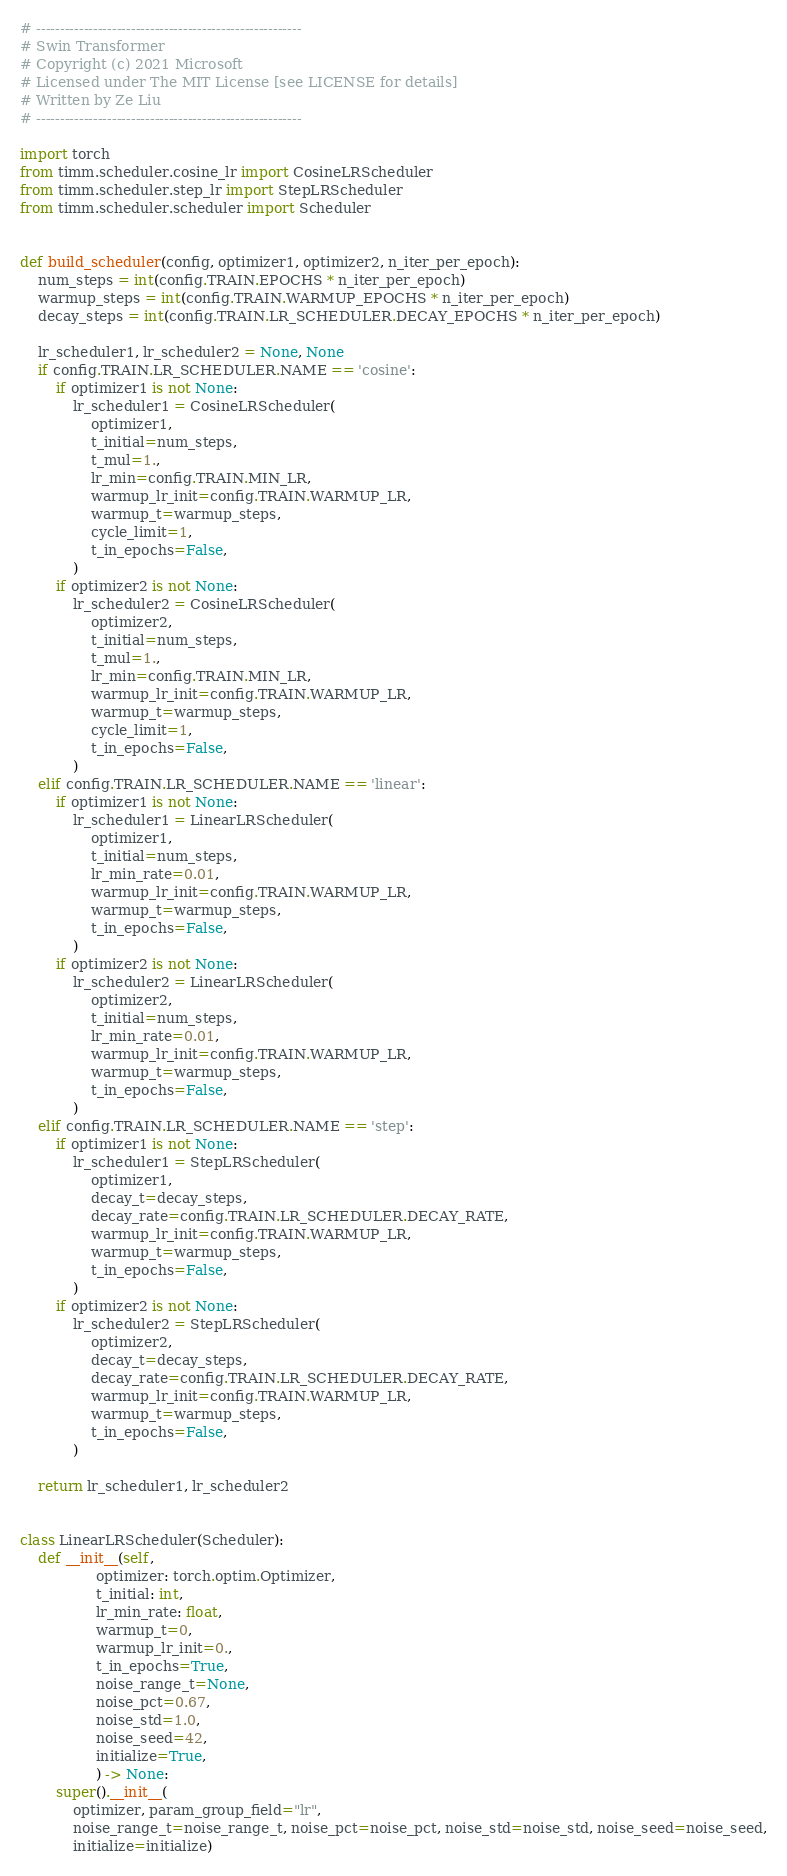<code> <loc_0><loc_0><loc_500><loc_500><_Python_># --------------------------------------------------------
# Swin Transformer
# Copyright (c) 2021 Microsoft
# Licensed under The MIT License [see LICENSE for details]
# Written by Ze Liu
# --------------------------------------------------------

import torch
from timm.scheduler.cosine_lr import CosineLRScheduler
from timm.scheduler.step_lr import StepLRScheduler
from timm.scheduler.scheduler import Scheduler


def build_scheduler(config, optimizer1, optimizer2, n_iter_per_epoch):
    num_steps = int(config.TRAIN.EPOCHS * n_iter_per_epoch)
    warmup_steps = int(config.TRAIN.WARMUP_EPOCHS * n_iter_per_epoch)
    decay_steps = int(config.TRAIN.LR_SCHEDULER.DECAY_EPOCHS * n_iter_per_epoch)

    lr_scheduler1, lr_scheduler2 = None, None
    if config.TRAIN.LR_SCHEDULER.NAME == 'cosine':
        if optimizer1 is not None:
            lr_scheduler1 = CosineLRScheduler(
                optimizer1,
                t_initial=num_steps,
                t_mul=1.,
                lr_min=config.TRAIN.MIN_LR,
                warmup_lr_init=config.TRAIN.WARMUP_LR,
                warmup_t=warmup_steps,
                cycle_limit=1,
                t_in_epochs=False,
            )
        if optimizer2 is not None:
            lr_scheduler2 = CosineLRScheduler(
                optimizer2,
                t_initial=num_steps,
                t_mul=1.,
                lr_min=config.TRAIN.MIN_LR,
                warmup_lr_init=config.TRAIN.WARMUP_LR,
                warmup_t=warmup_steps,
                cycle_limit=1,
                t_in_epochs=False,
            )
    elif config.TRAIN.LR_SCHEDULER.NAME == 'linear':
        if optimizer1 is not None:
            lr_scheduler1 = LinearLRScheduler(
                optimizer1,
                t_initial=num_steps,
                lr_min_rate=0.01,
                warmup_lr_init=config.TRAIN.WARMUP_LR,
                warmup_t=warmup_steps,
                t_in_epochs=False,
            )
        if optimizer2 is not None:
            lr_scheduler2 = LinearLRScheduler(
                optimizer2,
                t_initial=num_steps,
                lr_min_rate=0.01,
                warmup_lr_init=config.TRAIN.WARMUP_LR,
                warmup_t=warmup_steps,
                t_in_epochs=False,
            )
    elif config.TRAIN.LR_SCHEDULER.NAME == 'step':
        if optimizer1 is not None:
            lr_scheduler1 = StepLRScheduler(
                optimizer1,
                decay_t=decay_steps,
                decay_rate=config.TRAIN.LR_SCHEDULER.DECAY_RATE,
                warmup_lr_init=config.TRAIN.WARMUP_LR,
                warmup_t=warmup_steps,
                t_in_epochs=False,
            )
        if optimizer2 is not None:
            lr_scheduler2 = StepLRScheduler(
                optimizer2,
                decay_t=decay_steps,
                decay_rate=config.TRAIN.LR_SCHEDULER.DECAY_RATE,
                warmup_lr_init=config.TRAIN.WARMUP_LR,
                warmup_t=warmup_steps,
                t_in_epochs=False,
            )

    return lr_scheduler1, lr_scheduler2


class LinearLRScheduler(Scheduler):
    def __init__(self,
                 optimizer: torch.optim.Optimizer,
                 t_initial: int,
                 lr_min_rate: float,
                 warmup_t=0,
                 warmup_lr_init=0.,
                 t_in_epochs=True,
                 noise_range_t=None,
                 noise_pct=0.67,
                 noise_std=1.0,
                 noise_seed=42,
                 initialize=True,
                 ) -> None:
        super().__init__(
            optimizer, param_group_field="lr",
            noise_range_t=noise_range_t, noise_pct=noise_pct, noise_std=noise_std, noise_seed=noise_seed,
            initialize=initialize)
</code> 